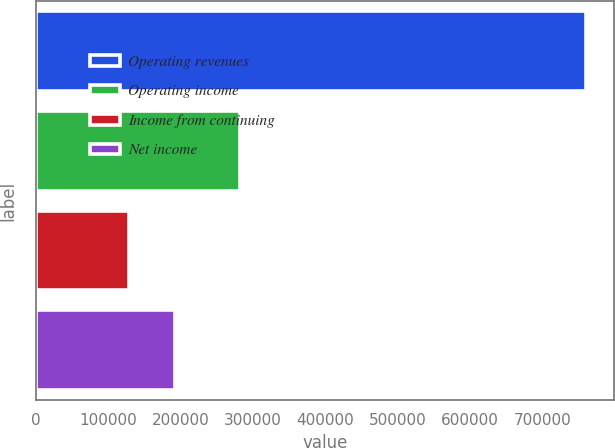Convert chart to OTSL. <chart><loc_0><loc_0><loc_500><loc_500><bar_chart><fcel>Operating revenues<fcel>Operating income<fcel>Income from continuing<fcel>Net income<nl><fcel>760869<fcel>281408<fcel>128495<fcel>191732<nl></chart> 